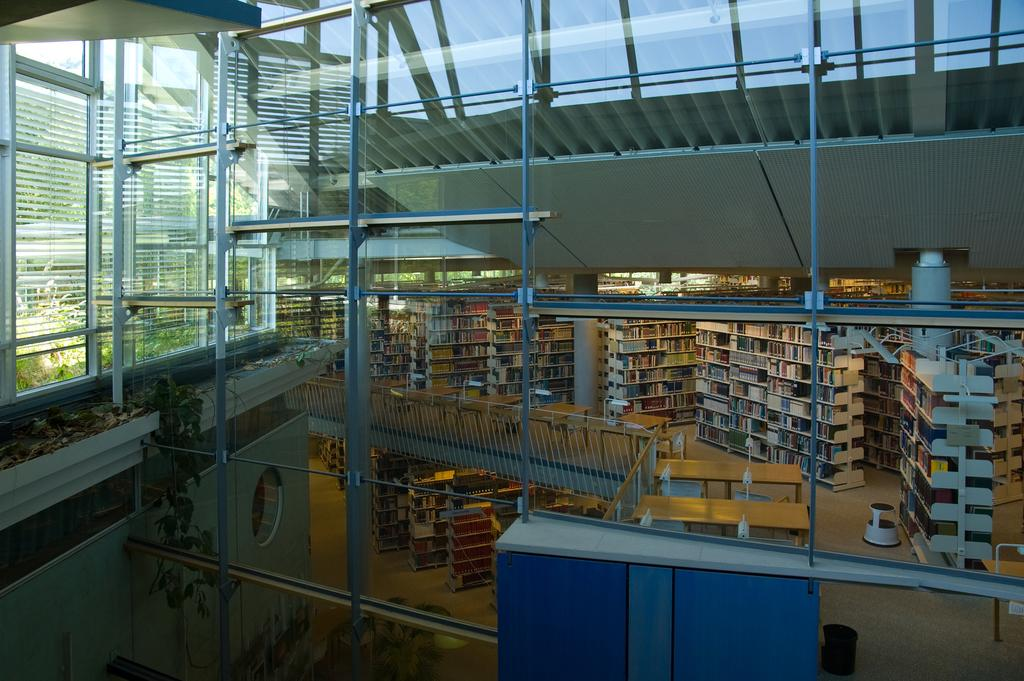What can be seen arranged in racks in the image? There are books arranged in racks in the image. What type of wall is present in the image? There is a glass wall in the image. What other objects can be seen in the image? There are rods in the image. What is located on the left side of the image? There is a wall on the left side of the image. What knowledge can be gained from the title of the book on the top shelf? There is no title visible on the books in the image, so it is not possible to determine any knowledge that could be gained from it. 